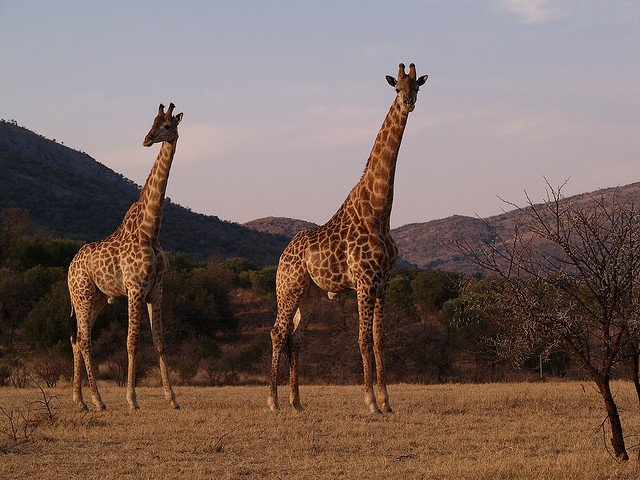Describe the objects in this image and their specific colors. I can see giraffe in darkgray, black, maroon, brown, and salmon tones and giraffe in darkgray, black, maroon, brown, and gray tones in this image. 